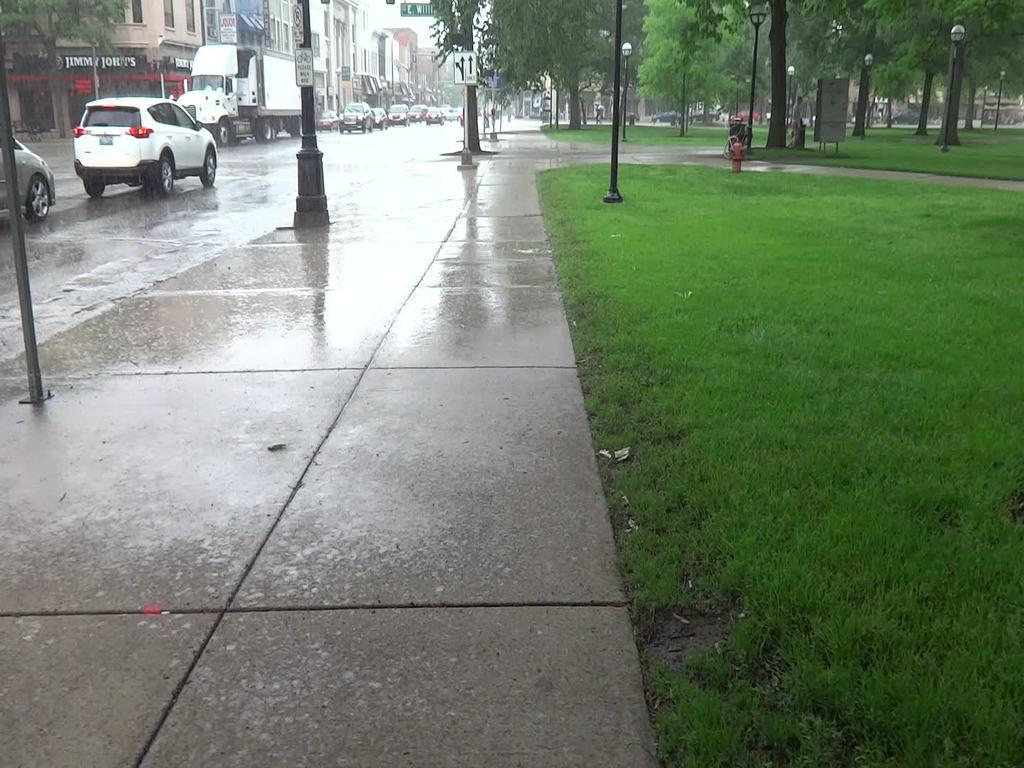What can be seen on the road in the image? There are vehicles on the road in the image. What structures are present alongside the road? There are light poles in the image. What type of vegetation is visible in the image? There are trees with green color in the image. What type of buildings can be seen in the image? There are buildings with brown and white colors in the image. What is the color of the sky in the image? The sky is in white color in the image. What is the income of the judge in the image? There is no judge present in the image, so it is not possible to determine their income. What type of wheel is attached to the vehicles in the image? The type of wheel attached to the vehicles cannot be determined from the image alone, as it only shows the vehicles on the road. 